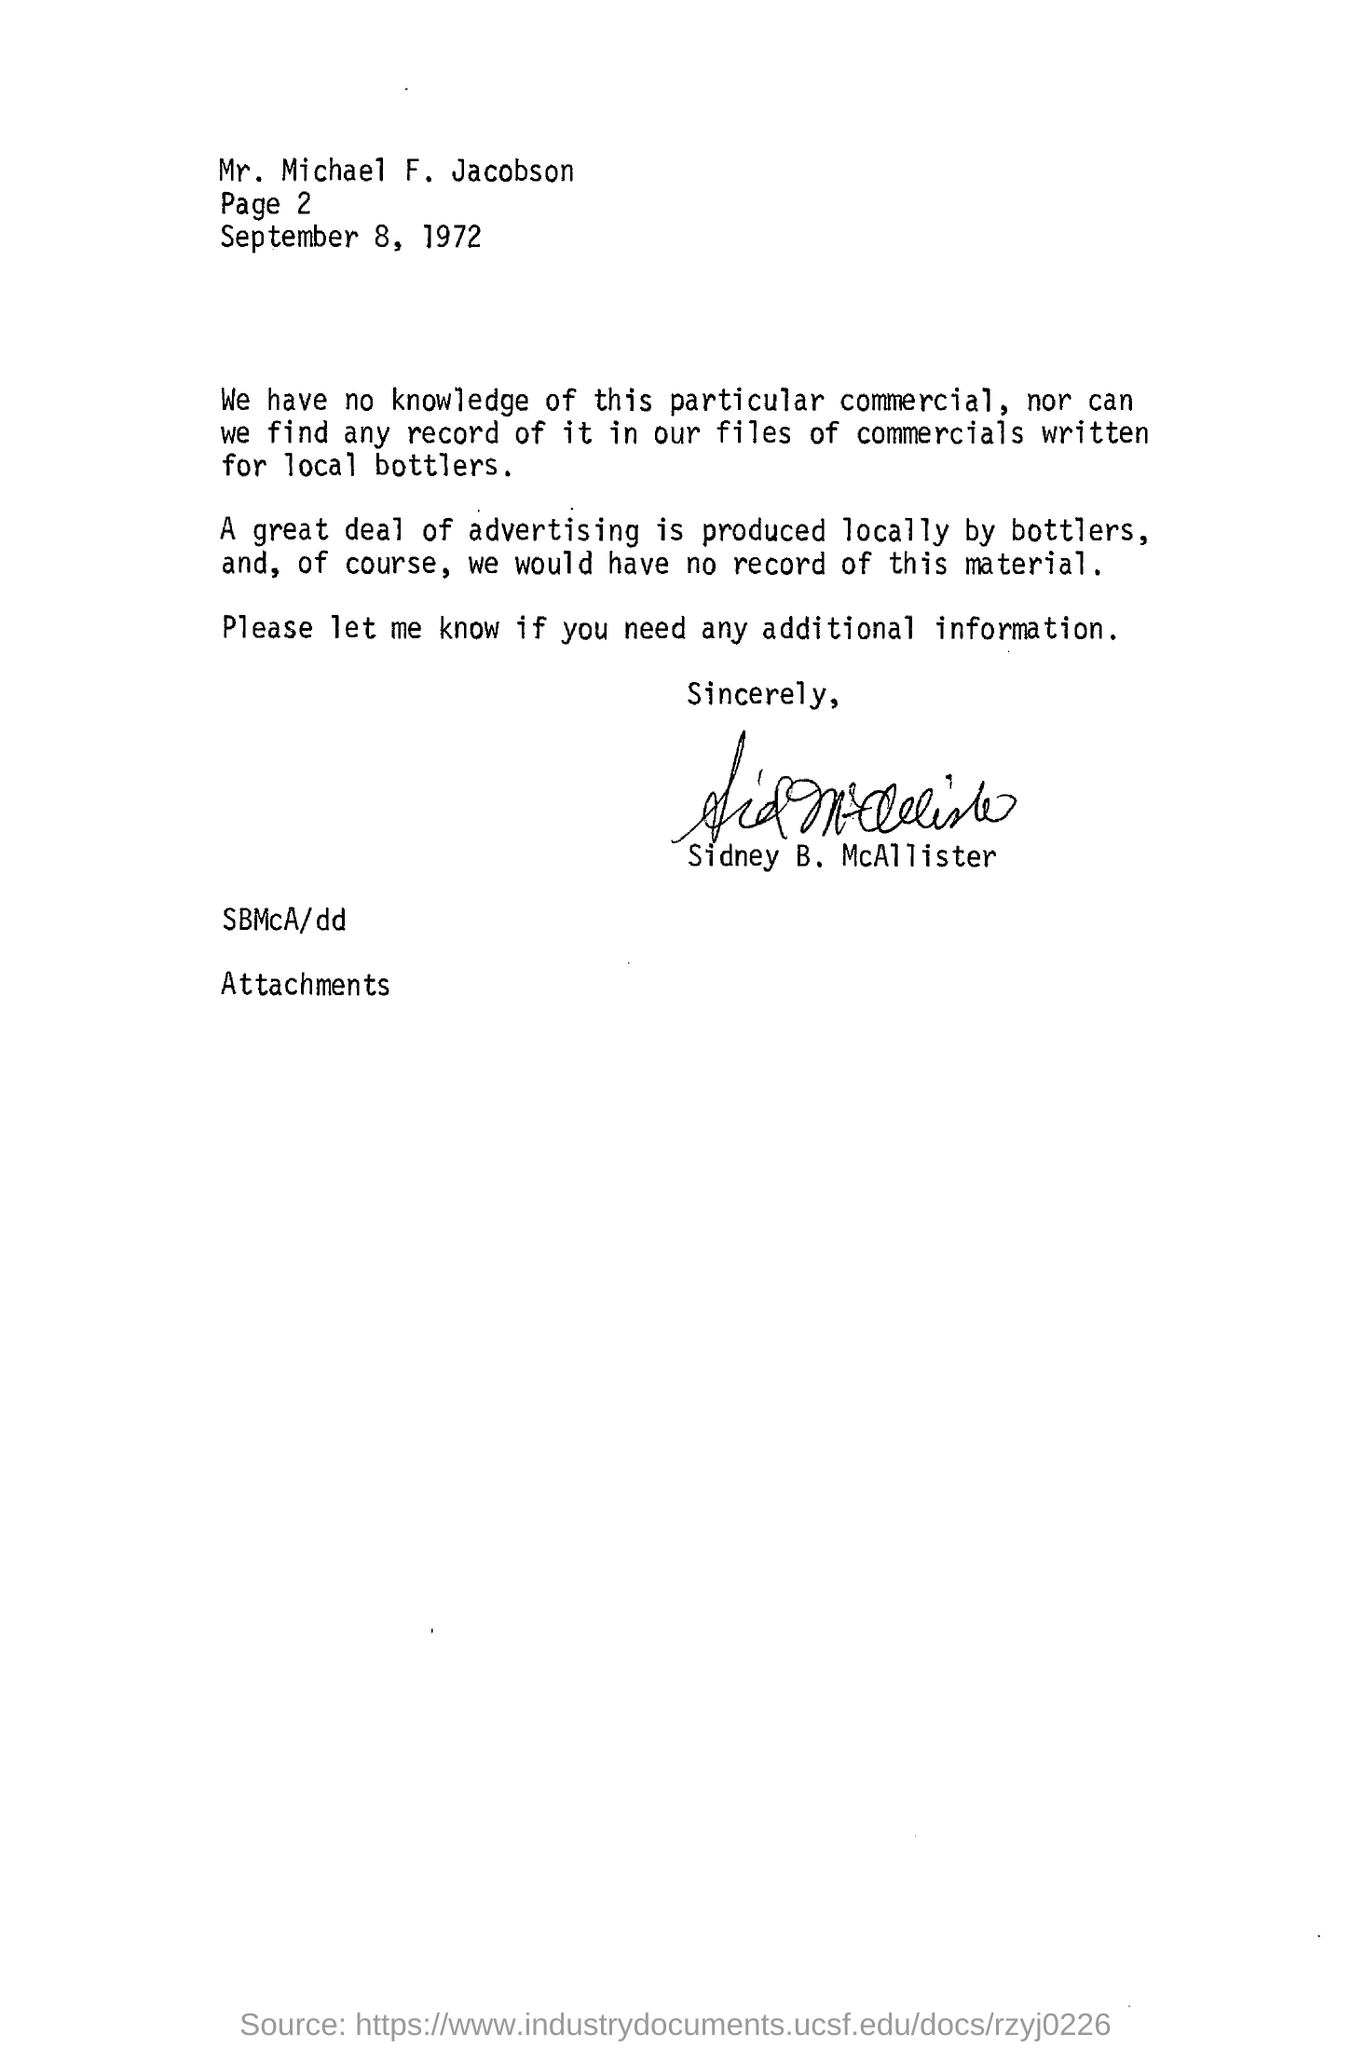By whom  a great deal of advertising is produced locally?
Your response must be concise. Bottlers,. 